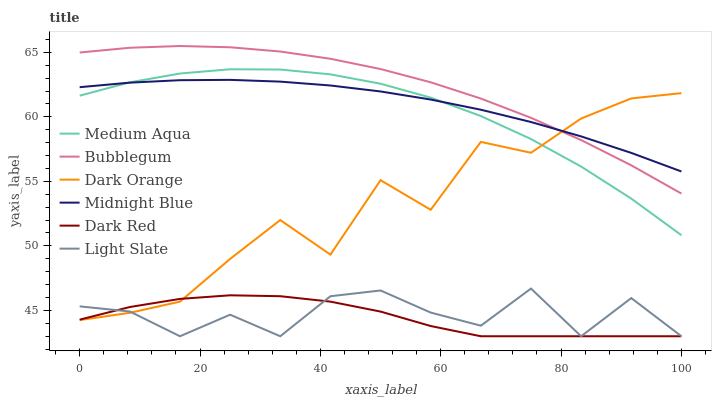Does Dark Red have the minimum area under the curve?
Answer yes or no. Yes. Does Bubblegum have the maximum area under the curve?
Answer yes or no. Yes. Does Midnight Blue have the minimum area under the curve?
Answer yes or no. No. Does Midnight Blue have the maximum area under the curve?
Answer yes or no. No. Is Midnight Blue the smoothest?
Answer yes or no. Yes. Is Dark Orange the roughest?
Answer yes or no. Yes. Is Light Slate the smoothest?
Answer yes or no. No. Is Light Slate the roughest?
Answer yes or no. No. Does Light Slate have the lowest value?
Answer yes or no. Yes. Does Midnight Blue have the lowest value?
Answer yes or no. No. Does Bubblegum have the highest value?
Answer yes or no. Yes. Does Midnight Blue have the highest value?
Answer yes or no. No. Is Dark Red less than Midnight Blue?
Answer yes or no. Yes. Is Midnight Blue greater than Dark Red?
Answer yes or no. Yes. Does Dark Red intersect Dark Orange?
Answer yes or no. Yes. Is Dark Red less than Dark Orange?
Answer yes or no. No. Is Dark Red greater than Dark Orange?
Answer yes or no. No. Does Dark Red intersect Midnight Blue?
Answer yes or no. No. 